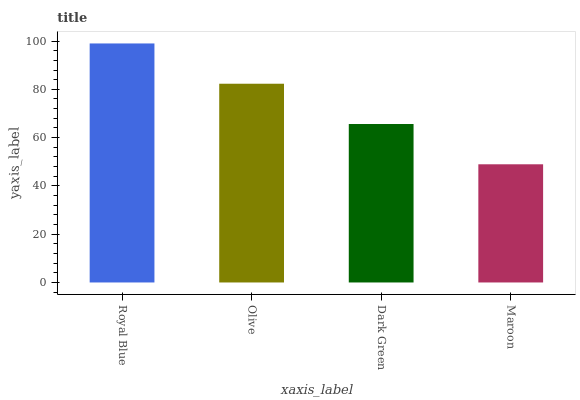Is Maroon the minimum?
Answer yes or no. Yes. Is Royal Blue the maximum?
Answer yes or no. Yes. Is Olive the minimum?
Answer yes or no. No. Is Olive the maximum?
Answer yes or no. No. Is Royal Blue greater than Olive?
Answer yes or no. Yes. Is Olive less than Royal Blue?
Answer yes or no. Yes. Is Olive greater than Royal Blue?
Answer yes or no. No. Is Royal Blue less than Olive?
Answer yes or no. No. Is Olive the high median?
Answer yes or no. Yes. Is Dark Green the low median?
Answer yes or no. Yes. Is Dark Green the high median?
Answer yes or no. No. Is Maroon the low median?
Answer yes or no. No. 